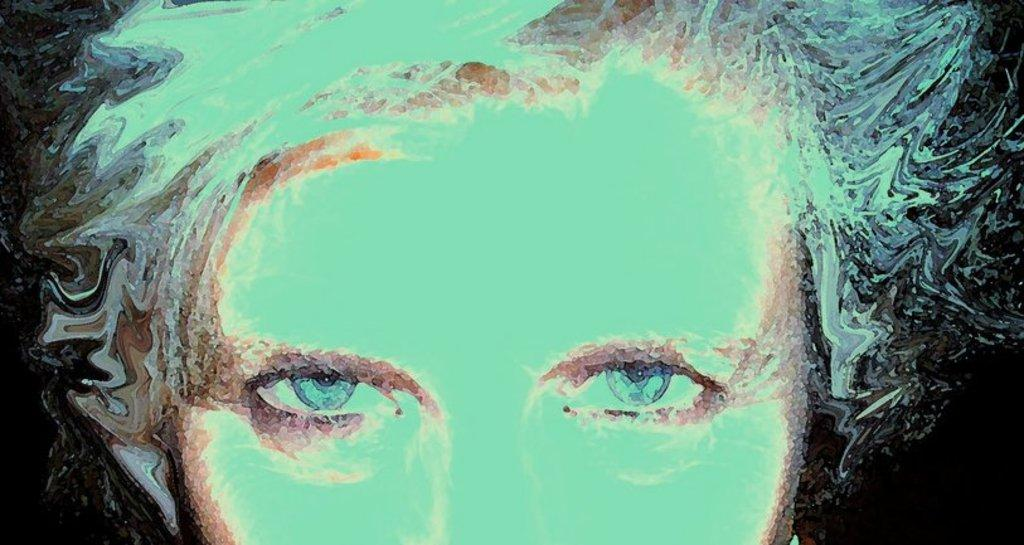What is depicted in the painting in the image? There is a painting of a person's face in the image. What color is the background of the painting? The background of the painting is black. What type of brush can be seen in the painting in the image? There is no brush visible in the painting or the image. What sound can be heard coming from the painting in the image? There is no sound coming from the painting or the image, as paintings are silent. 